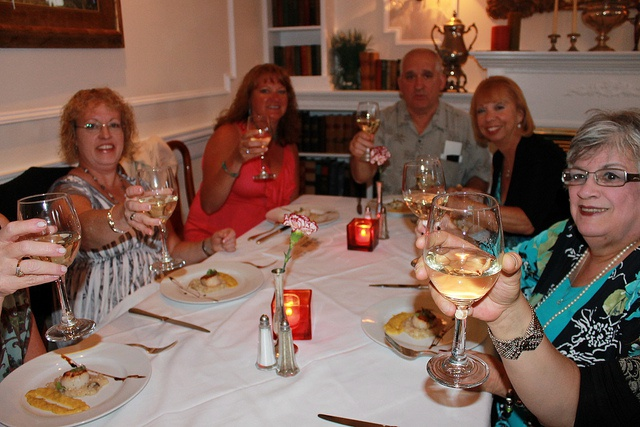Describe the objects in this image and their specific colors. I can see dining table in maroon, darkgray, lightgray, and gray tones, people in maroon, black, brown, gray, and teal tones, people in maroon, brown, darkgray, and gray tones, people in maroon, brown, and black tones, and people in maroon, black, gray, and tan tones in this image. 